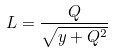<formula> <loc_0><loc_0><loc_500><loc_500>L = \frac { Q } { \sqrt { y + Q ^ { 2 } } }</formula> 